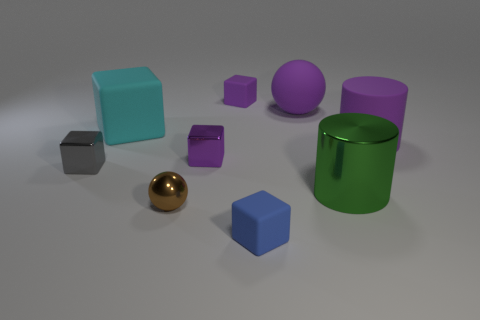Subtract all cyan blocks. How many blocks are left? 4 Subtract 1 blocks. How many blocks are left? 4 Add 1 large green cylinders. How many objects exist? 10 Subtract all spheres. How many objects are left? 7 Subtract all brown things. Subtract all brown balls. How many objects are left? 7 Add 9 large green metal objects. How many large green metal objects are left? 10 Add 3 large yellow objects. How many large yellow objects exist? 3 Subtract all brown spheres. How many spheres are left? 1 Subtract 0 yellow cylinders. How many objects are left? 9 Subtract all gray cylinders. Subtract all purple cubes. How many cylinders are left? 2 